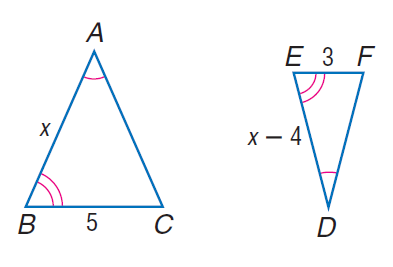Question: Find D E.
Choices:
A. 6
B. 8
C. 9
D. 11
Answer with the letter. Answer: A 